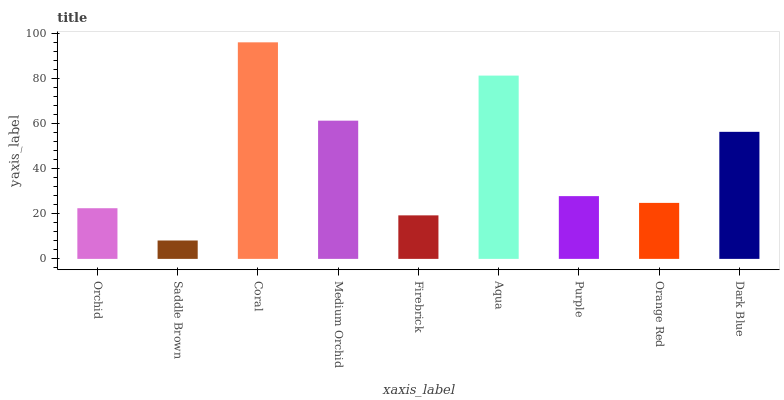Is Saddle Brown the minimum?
Answer yes or no. Yes. Is Coral the maximum?
Answer yes or no. Yes. Is Coral the minimum?
Answer yes or no. No. Is Saddle Brown the maximum?
Answer yes or no. No. Is Coral greater than Saddle Brown?
Answer yes or no. Yes. Is Saddle Brown less than Coral?
Answer yes or no. Yes. Is Saddle Brown greater than Coral?
Answer yes or no. No. Is Coral less than Saddle Brown?
Answer yes or no. No. Is Purple the high median?
Answer yes or no. Yes. Is Purple the low median?
Answer yes or no. Yes. Is Orange Red the high median?
Answer yes or no. No. Is Coral the low median?
Answer yes or no. No. 